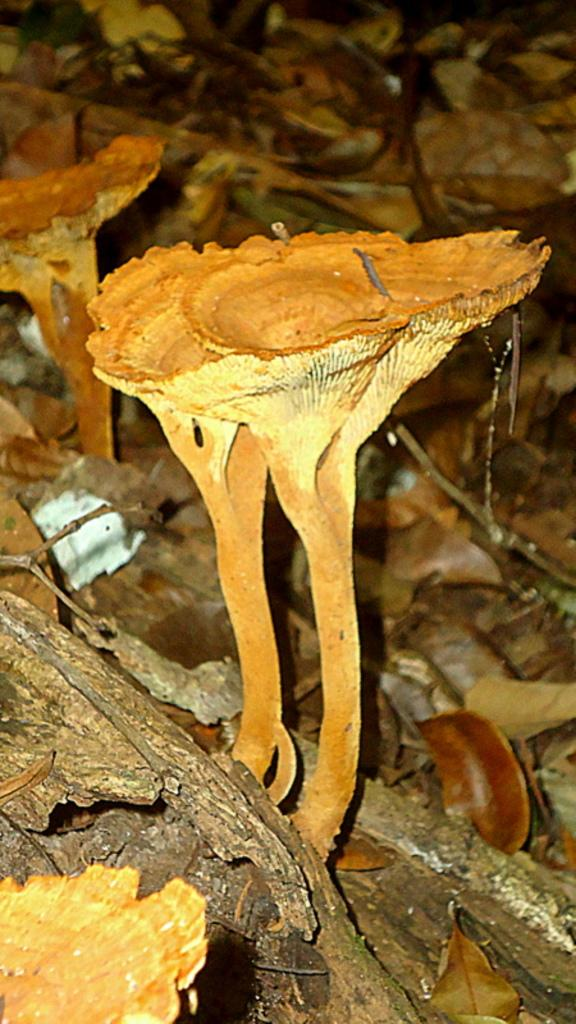What is the main subject of the image? The main subject of the image is a mushroom. Can you describe the colors of the mushroom? The mushroom has brown and cream colors. What else is visible near the mushroom in the image? The mushroom is near sticks. How would you describe the background of the image? The background of the image is blurred. How many frogs are sitting on the mushroom in the image? There are no frogs present in the image; it only features a mushroom and some sticks. What type of goose can be seen interacting with the mushroom in the image? There is no goose present in the image; only the mushroom and sticks are visible. 